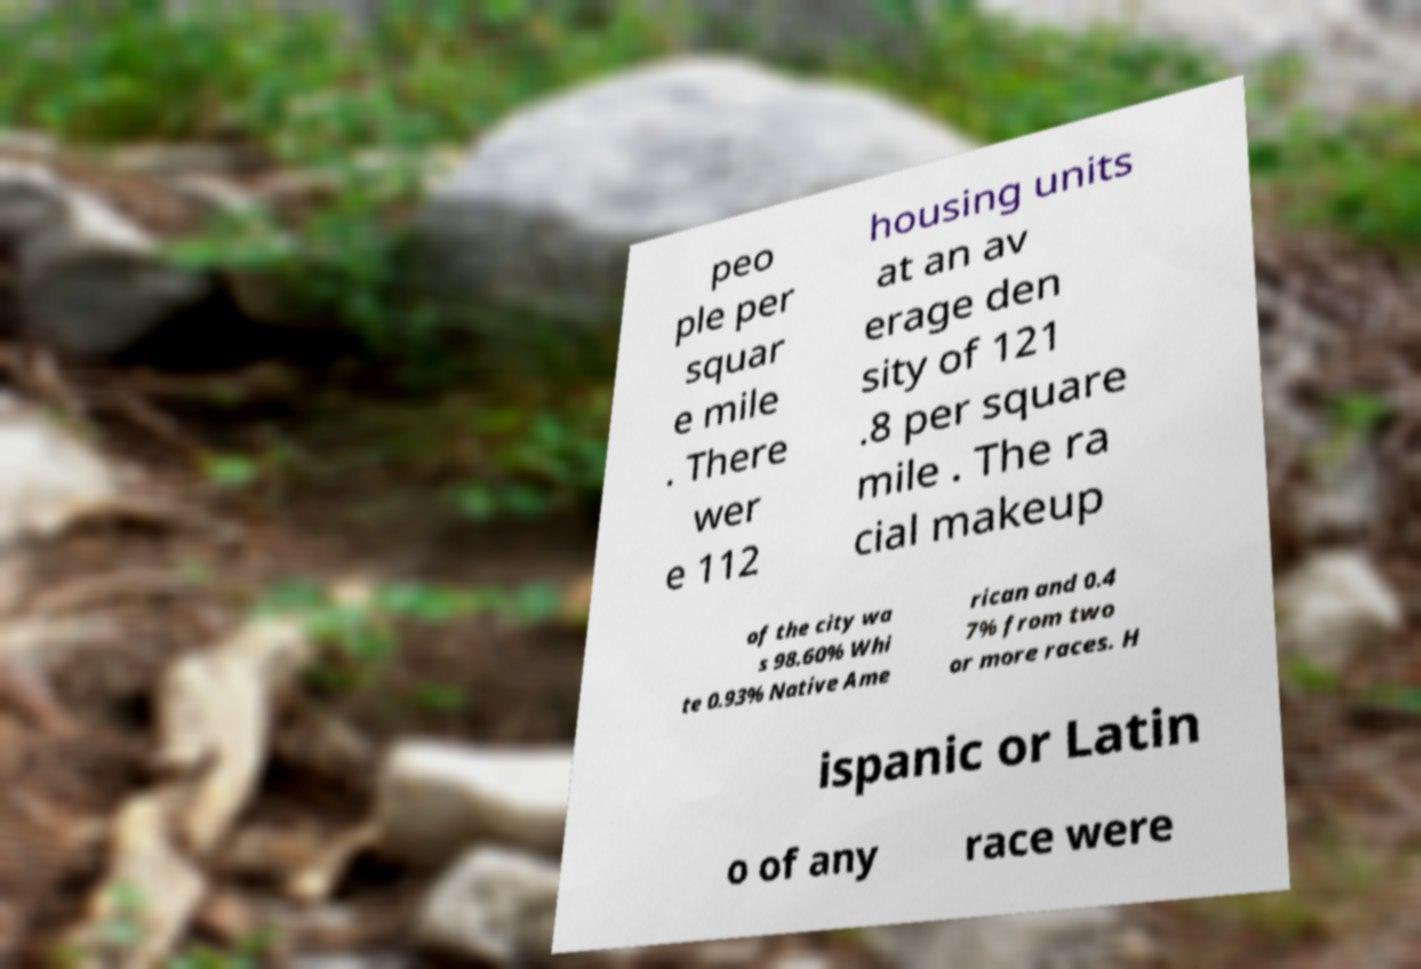Could you extract and type out the text from this image? peo ple per squar e mile . There wer e 112 housing units at an av erage den sity of 121 .8 per square mile . The ra cial makeup of the city wa s 98.60% Whi te 0.93% Native Ame rican and 0.4 7% from two or more races. H ispanic or Latin o of any race were 